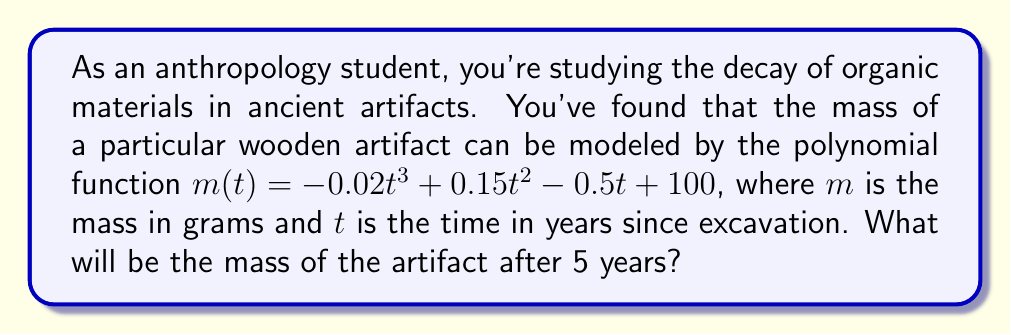Can you answer this question? To find the mass of the artifact after 5 years, we need to evaluate the given polynomial function at $t = 5$. Let's break this down step-by-step:

1) The given function is:
   $m(t) = -0.02t^3 + 0.15t^2 - 0.5t + 100$

2) We need to calculate $m(5)$, so let's substitute $t = 5$ into the equation:
   $m(5) = -0.02(5^3) + 0.15(5^2) - 0.5(5) + 100$

3) Let's evaluate each term:
   - $-0.02(5^3) = -0.02(125) = -2.5$
   - $0.15(5^2) = 0.15(25) = 3.75$
   - $-0.5(5) = -2.5$
   - $100$ remains as is

4) Now, let's add all these terms:
   $m(5) = -2.5 + 3.75 - 2.5 + 100 = 98.75$

Therefore, after 5 years, the mass of the artifact will be 98.75 grams.
Answer: 98.75 grams 